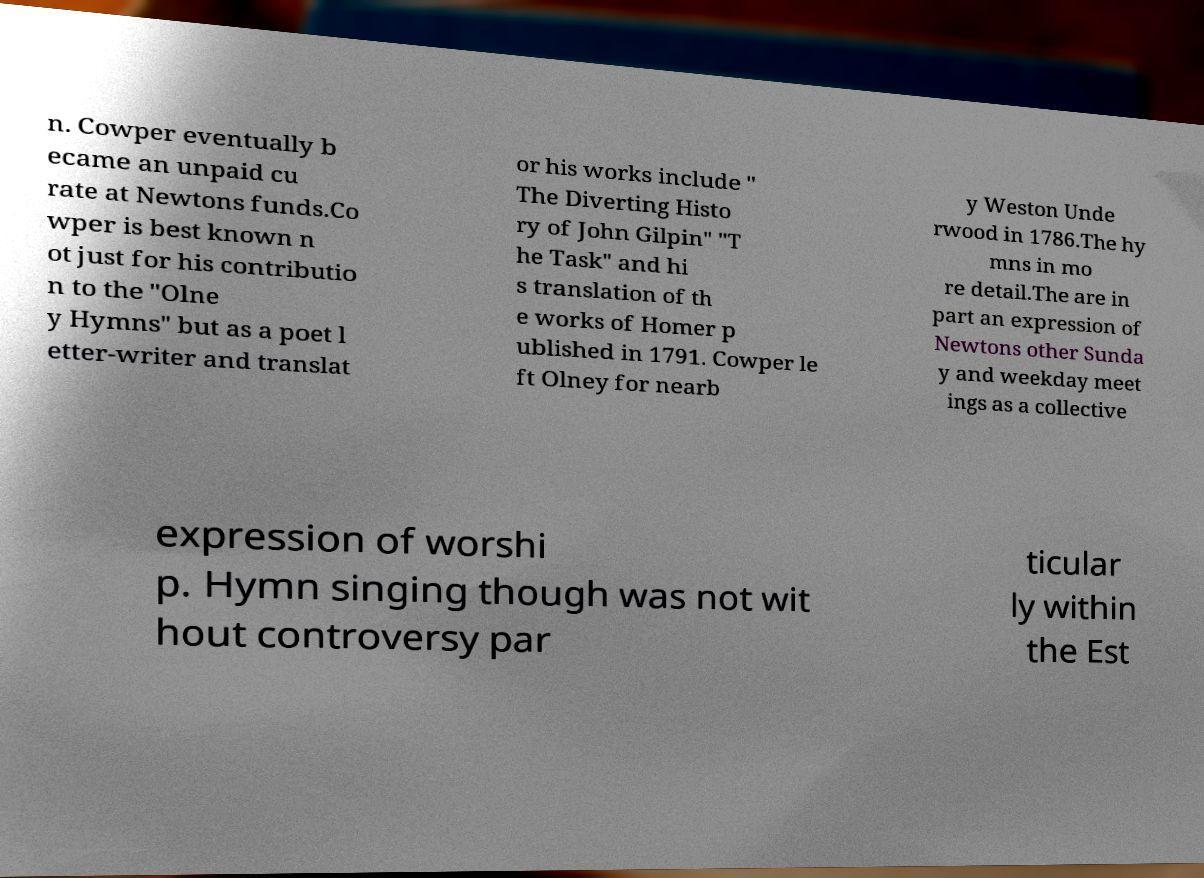What messages or text are displayed in this image? I need them in a readable, typed format. n. Cowper eventually b ecame an unpaid cu rate at Newtons funds.Co wper is best known n ot just for his contributio n to the "Olne y Hymns" but as a poet l etter-writer and translat or his works include " The Diverting Histo ry of John Gilpin" "T he Task" and hi s translation of th e works of Homer p ublished in 1791. Cowper le ft Olney for nearb y Weston Unde rwood in 1786.The hy mns in mo re detail.The are in part an expression of Newtons other Sunda y and weekday meet ings as a collective expression of worshi p. Hymn singing though was not wit hout controversy par ticular ly within the Est 